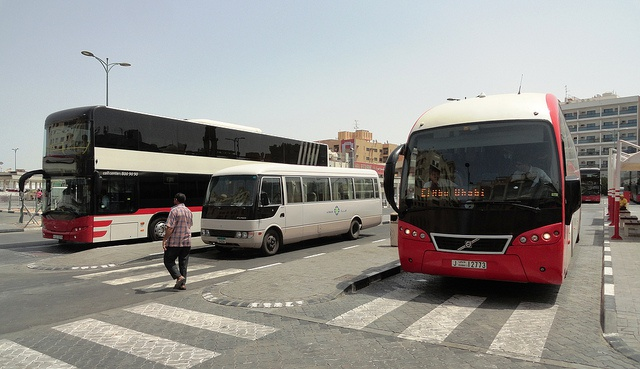Describe the objects in this image and their specific colors. I can see bus in darkgray, black, maroon, gray, and ivory tones, bus in darkgray, black, gray, and beige tones, bus in darkgray, black, gray, and ivory tones, people in darkgray, black, and gray tones, and people in darkgray, black, and gray tones in this image. 